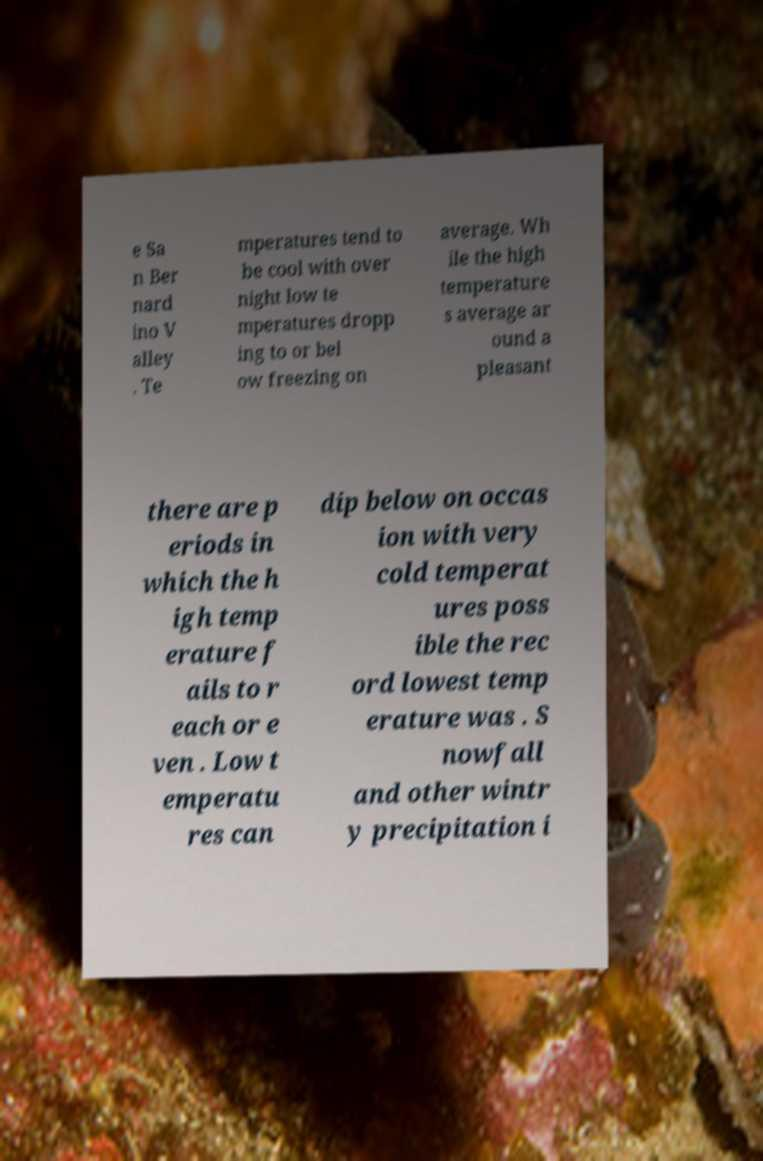Please read and relay the text visible in this image. What does it say? e Sa n Ber nard ino V alley . Te mperatures tend to be cool with over night low te mperatures dropp ing to or bel ow freezing on average. Wh ile the high temperature s average ar ound a pleasant there are p eriods in which the h igh temp erature f ails to r each or e ven . Low t emperatu res can dip below on occas ion with very cold temperat ures poss ible the rec ord lowest temp erature was . S nowfall and other wintr y precipitation i 